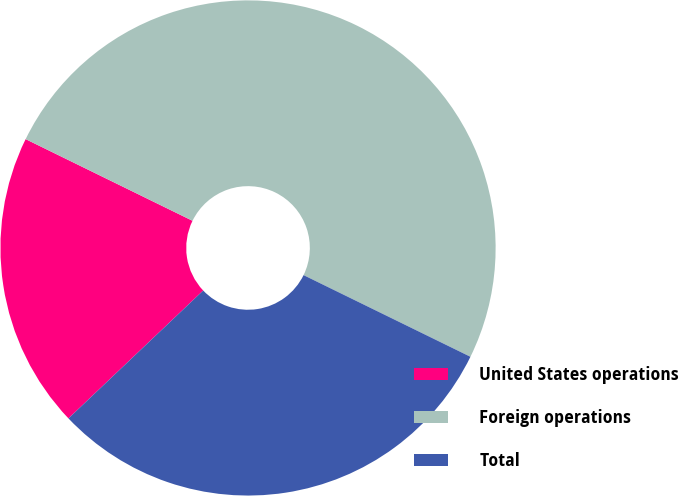<chart> <loc_0><loc_0><loc_500><loc_500><pie_chart><fcel>United States operations<fcel>Foreign operations<fcel>Total<nl><fcel>19.33%<fcel>50.0%<fcel>30.67%<nl></chart> 